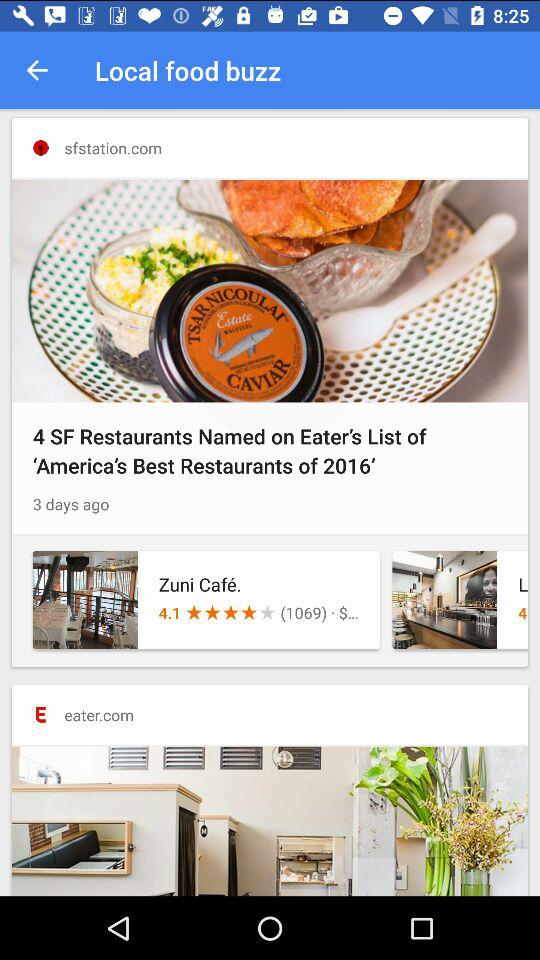What is the star rating of "Zuni Café"? The rating is 4.1 stars. 